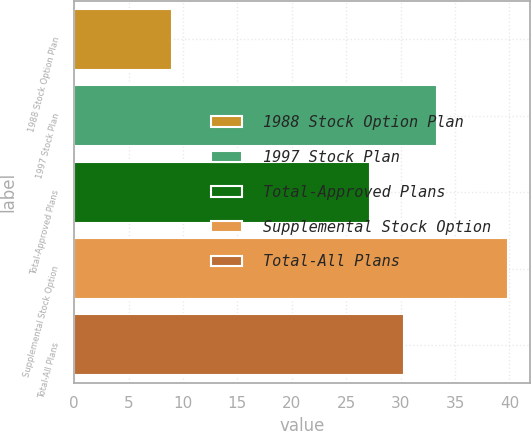<chart> <loc_0><loc_0><loc_500><loc_500><bar_chart><fcel>1988 Stock Option Plan<fcel>1997 Stock Plan<fcel>Total-Approved Plans<fcel>Supplemental Stock Option<fcel>Total-All Plans<nl><fcel>8.99<fcel>33.38<fcel>27.2<fcel>39.85<fcel>30.29<nl></chart> 